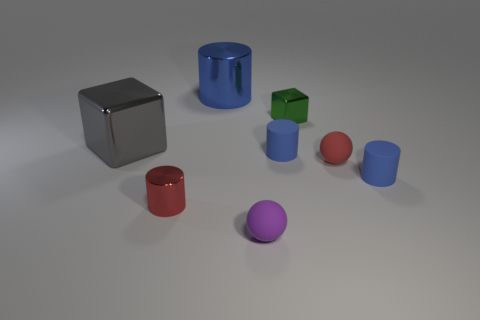Subtract all red spheres. How many blue cylinders are left? 3 Add 1 big gray things. How many objects exist? 9 Subtract all spheres. How many objects are left? 6 Add 1 big cyan objects. How many big cyan objects exist? 1 Subtract 0 green spheres. How many objects are left? 8 Subtract all yellow matte objects. Subtract all metallic cubes. How many objects are left? 6 Add 4 red objects. How many red objects are left? 6 